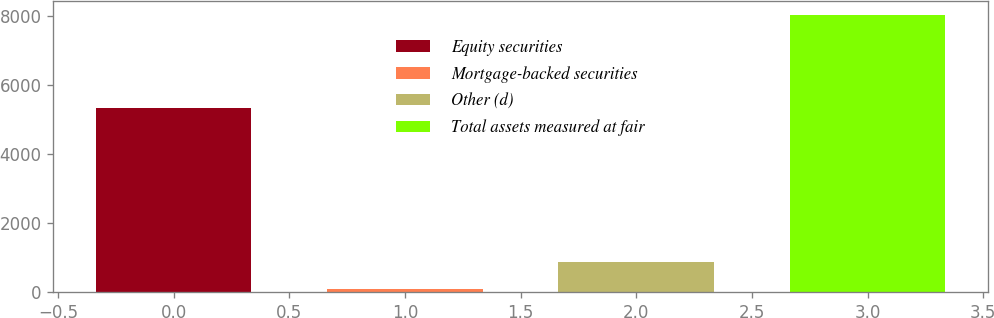Convert chart to OTSL. <chart><loc_0><loc_0><loc_500><loc_500><bar_chart><fcel>Equity securities<fcel>Mortgage-backed securities<fcel>Other (d)<fcel>Total assets measured at fair<nl><fcel>5342<fcel>82<fcel>885<fcel>8044<nl></chart> 